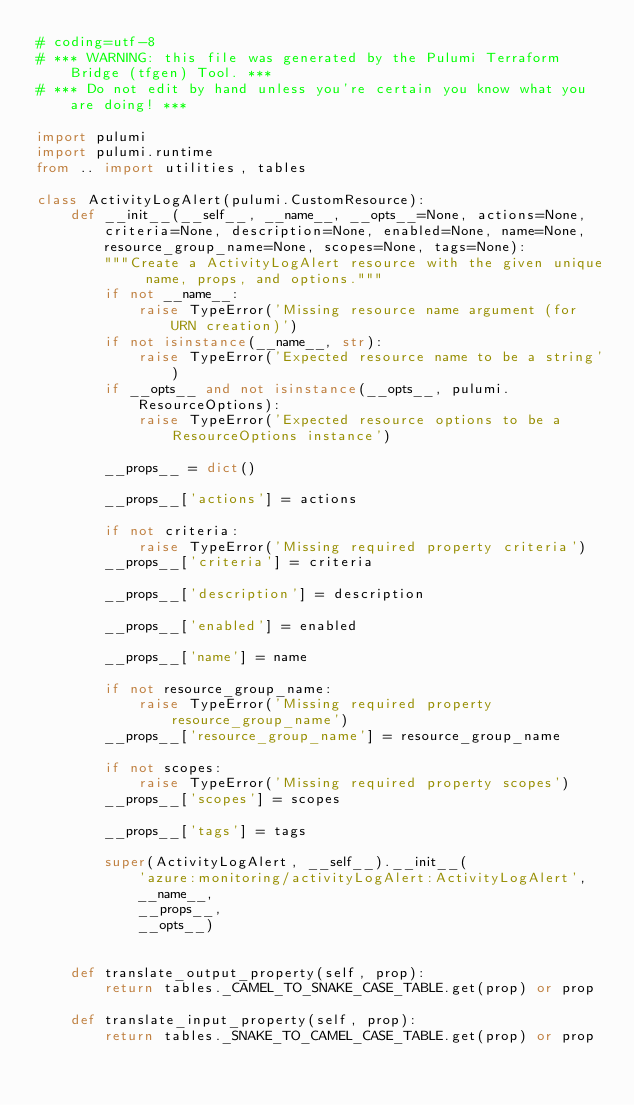Convert code to text. <code><loc_0><loc_0><loc_500><loc_500><_Python_># coding=utf-8
# *** WARNING: this file was generated by the Pulumi Terraform Bridge (tfgen) Tool. ***
# *** Do not edit by hand unless you're certain you know what you are doing! ***

import pulumi
import pulumi.runtime
from .. import utilities, tables

class ActivityLogAlert(pulumi.CustomResource):
    def __init__(__self__, __name__, __opts__=None, actions=None, criteria=None, description=None, enabled=None, name=None, resource_group_name=None, scopes=None, tags=None):
        """Create a ActivityLogAlert resource with the given unique name, props, and options."""
        if not __name__:
            raise TypeError('Missing resource name argument (for URN creation)')
        if not isinstance(__name__, str):
            raise TypeError('Expected resource name to be a string')
        if __opts__ and not isinstance(__opts__, pulumi.ResourceOptions):
            raise TypeError('Expected resource options to be a ResourceOptions instance')

        __props__ = dict()

        __props__['actions'] = actions

        if not criteria:
            raise TypeError('Missing required property criteria')
        __props__['criteria'] = criteria

        __props__['description'] = description

        __props__['enabled'] = enabled

        __props__['name'] = name

        if not resource_group_name:
            raise TypeError('Missing required property resource_group_name')
        __props__['resource_group_name'] = resource_group_name

        if not scopes:
            raise TypeError('Missing required property scopes')
        __props__['scopes'] = scopes

        __props__['tags'] = tags

        super(ActivityLogAlert, __self__).__init__(
            'azure:monitoring/activityLogAlert:ActivityLogAlert',
            __name__,
            __props__,
            __opts__)


    def translate_output_property(self, prop):
        return tables._CAMEL_TO_SNAKE_CASE_TABLE.get(prop) or prop

    def translate_input_property(self, prop):
        return tables._SNAKE_TO_CAMEL_CASE_TABLE.get(prop) or prop

</code> 